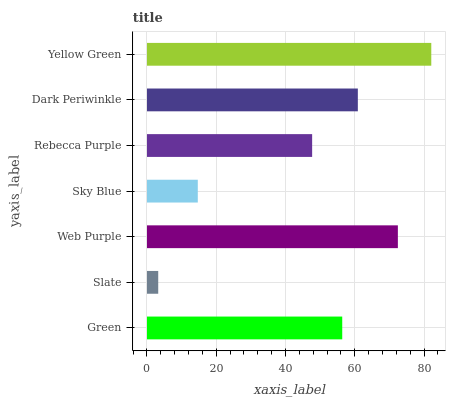Is Slate the minimum?
Answer yes or no. Yes. Is Yellow Green the maximum?
Answer yes or no. Yes. Is Web Purple the minimum?
Answer yes or no. No. Is Web Purple the maximum?
Answer yes or no. No. Is Web Purple greater than Slate?
Answer yes or no. Yes. Is Slate less than Web Purple?
Answer yes or no. Yes. Is Slate greater than Web Purple?
Answer yes or no. No. Is Web Purple less than Slate?
Answer yes or no. No. Is Green the high median?
Answer yes or no. Yes. Is Green the low median?
Answer yes or no. Yes. Is Dark Periwinkle the high median?
Answer yes or no. No. Is Rebecca Purple the low median?
Answer yes or no. No. 